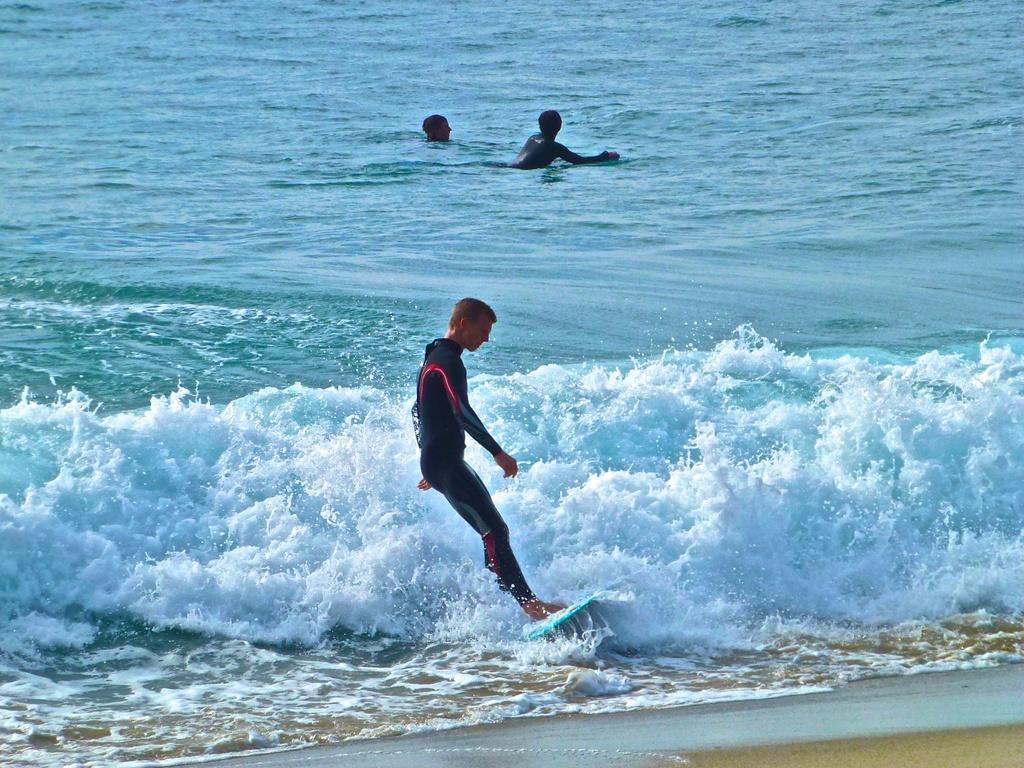In one or two sentences, can you explain what this image depicts? In the picture we can see the ocean with blue color water and in it we can see a man surfing on the surfboard and two people are swimming in the water and near to the water we can see a path with sand. 